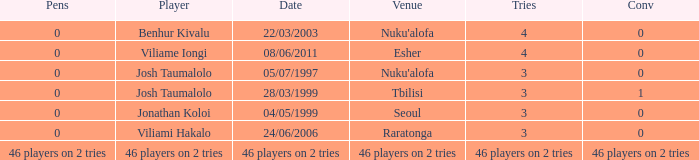What player played on 04/05/1999 with a conv of 0? Jonathan Koloi. 